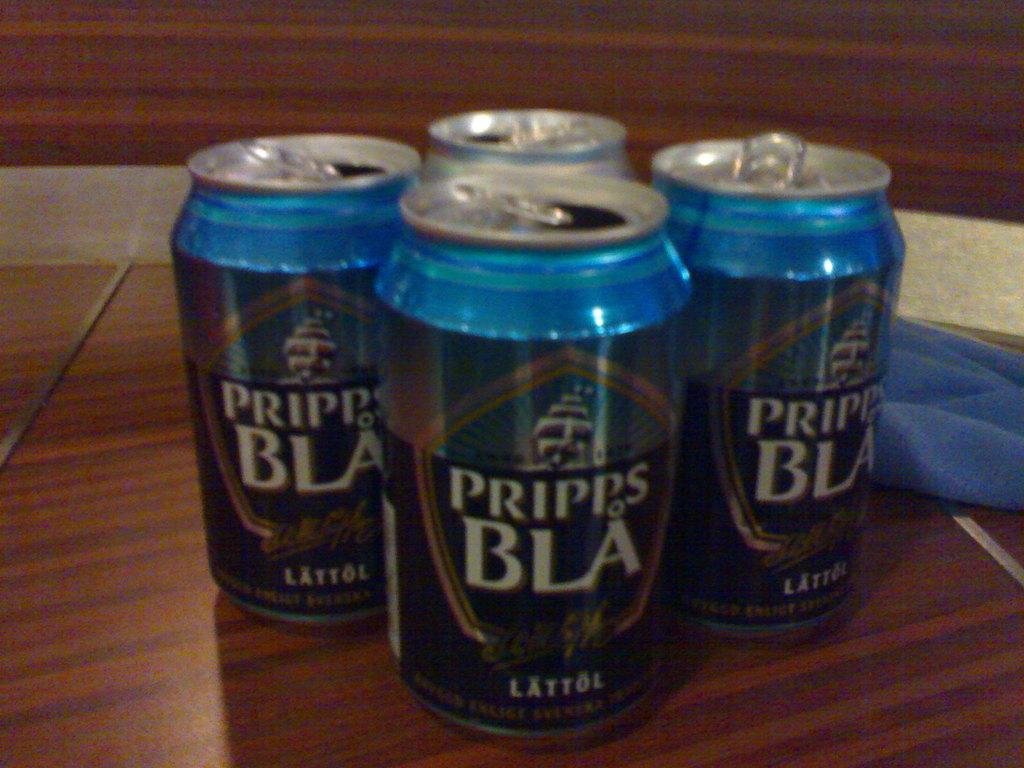<image>
Present a compact description of the photo's key features. Four empty cans of Pripps BLA on a brown table. 